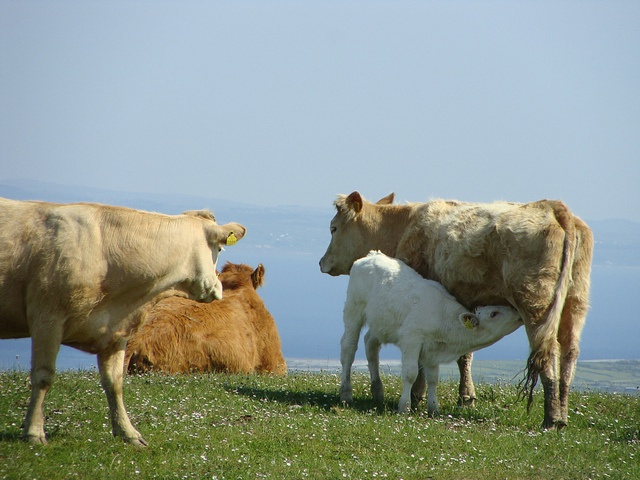Describe the objects in this image and their specific colors. I can see cow in darkgray, tan, olive, and black tones, cow in darkgray, darkgreen, black, tan, and gray tones, cow in darkgray, gray, black, and darkgreen tones, and cow in darkgray, olive, and tan tones in this image. 